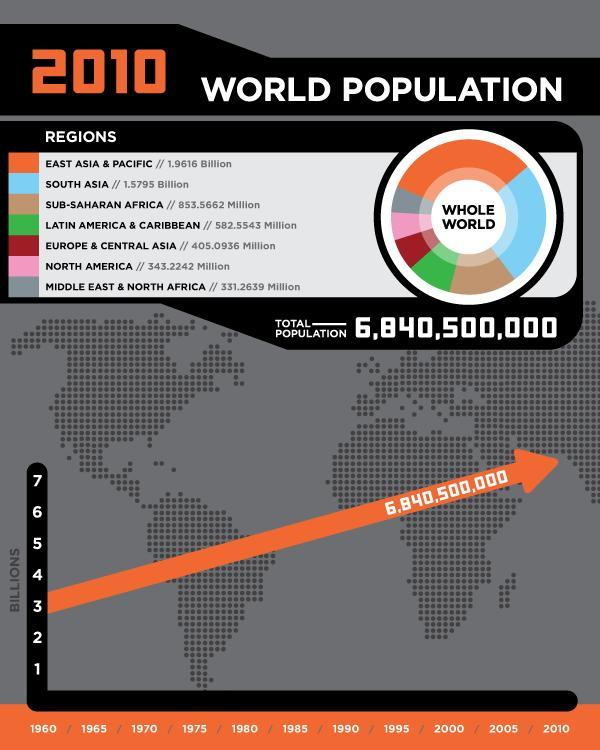what is the total population (in millions) of North America, Latin America and Caribbean taken together?
Answer the question with a short phrase. 925.7785 which of the given regions has the fourth largest population? Latin America & Caribbean which of the given regions has the smallest population? Middle East & North Africa what is the total population (in billions) of central Asia, South Asia and Europe taken together? 1.9845936 which region is has more population - South Asia or North America? South Asia which of the given regions has the second largest population? South Asia what is the total population (in millions) of Sub-Saharan Africa, Middle East and North Africa taken together? 1184.8301 which region is has more population - North America or Latin America & Caribbean? Latin America & Caribbean which of the given regions has the largest population? East Asia & Pacific which region is has more population - South Asia or Sub-Saharan Africa? South Asia which of the given regions has the third largest population? Sub-Saharan Africa what is the total population (in billions) of East Asia Pacific and South Asia taken together? 3.5411 which region is has more population - Sub-Saharan Africa or North Africa & middle east? Sub-Saharan Africa what is the total population (in billions) of east Asia & Pacific, South Asia and Sub-Saharan Africa taken together? 4.3946 